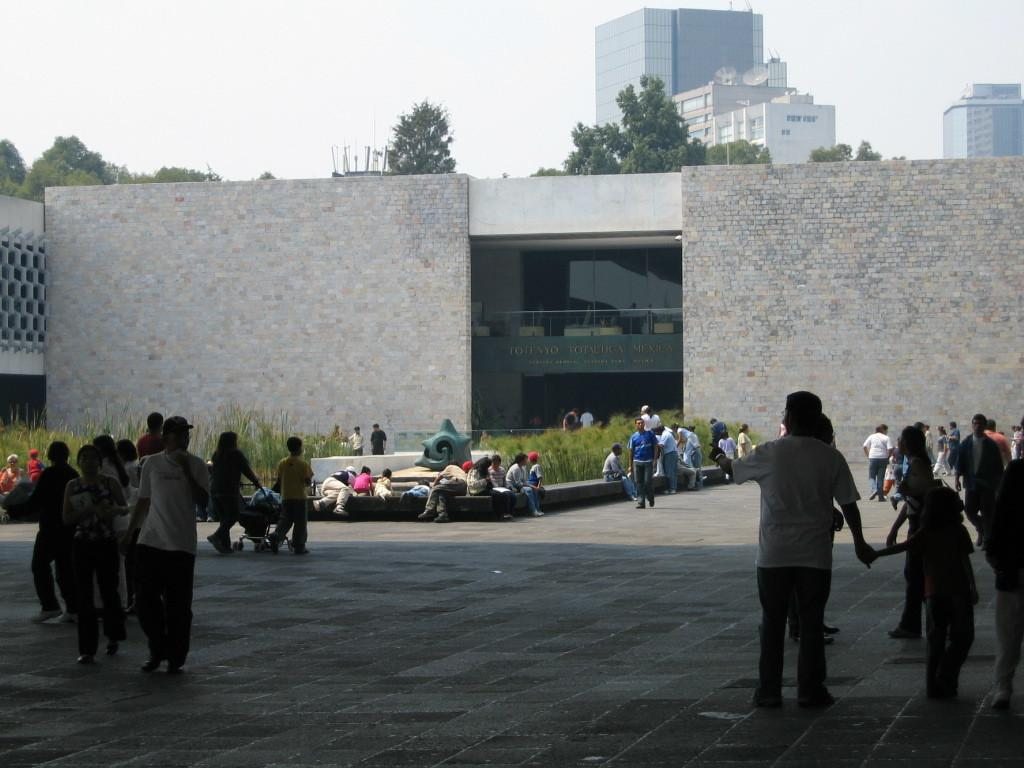What is happening with the group of people in the image? The group of people is waiting on the ground. Can you describe the setting of the image? There is a big brick wall and trees visible in the background of the image, along with buildings. What type of unit is being used to measure the distance between the trees in the image? There is no unit or measurement being shown in the image; it simply depicts a group of people waiting and a background with a brick wall, trees, and buildings. 